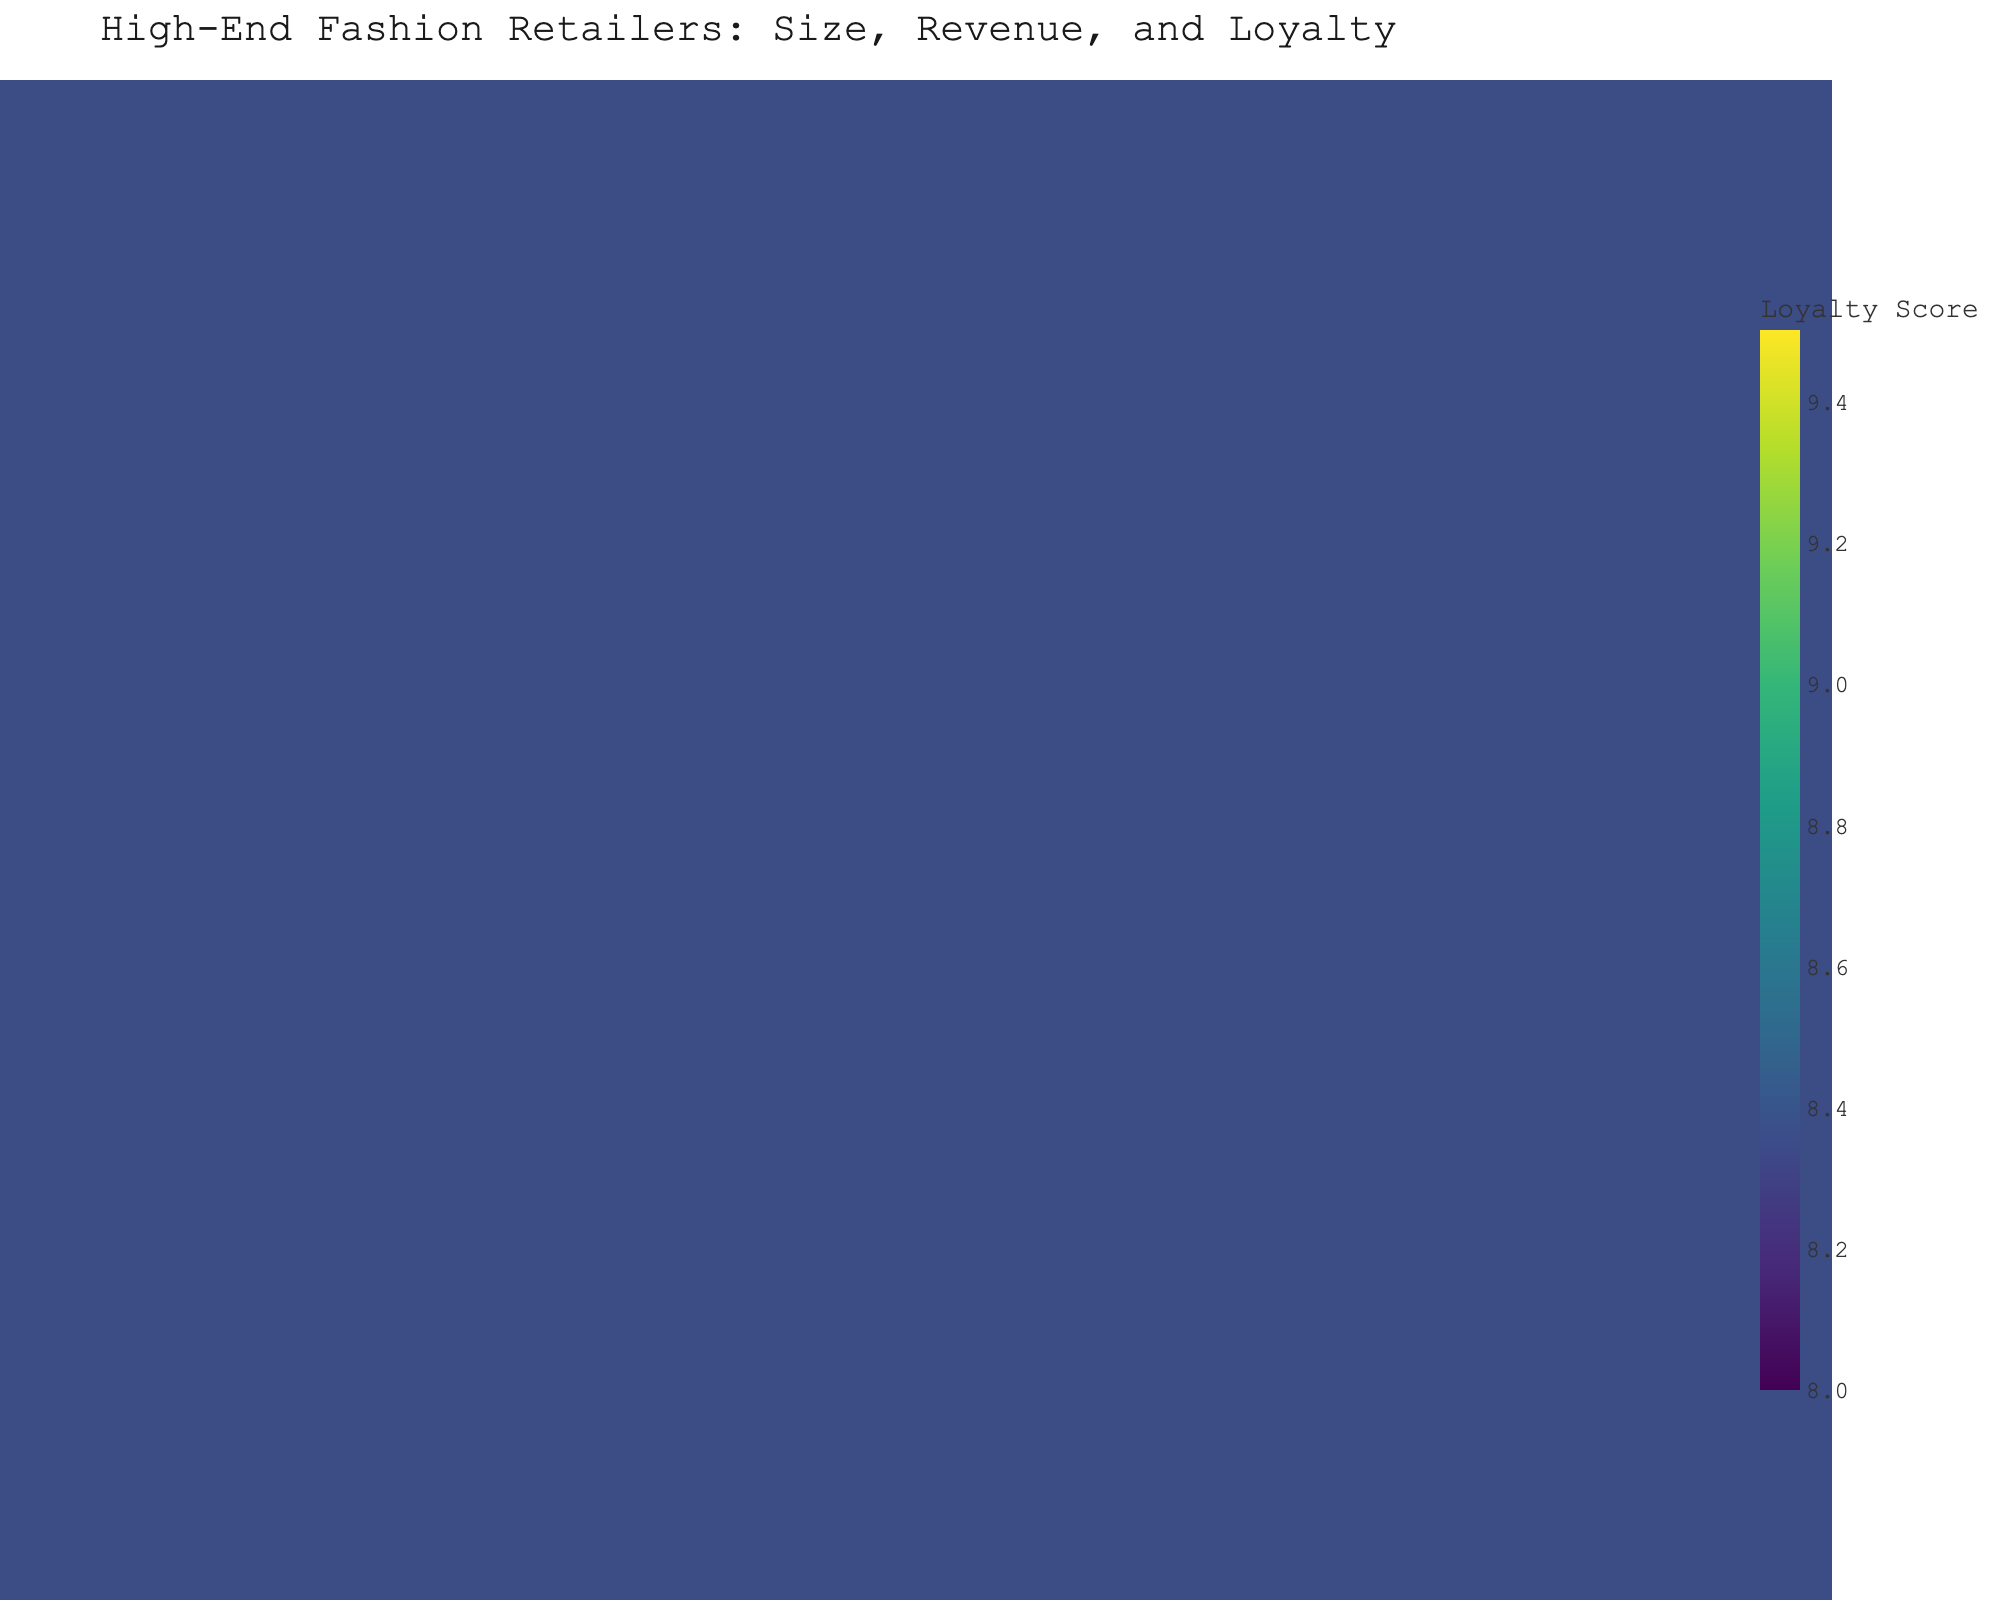What is the title of the plot? The title is usually displayed at the top of the figure, giving an overview of the chart's content.
Answer: High-End Fashion Retailers: Size, Revenue, and Loyalty Which store has the highest annual revenue? Look for the data point on the y-axis with the highest value and refer to the hover name.
Answer: Louis Vuitton How many stores are plotted in the figure? Count the number of distinct data points or markers in the scatter plot.
Answer: 15 Which store has the lowest customer loyalty score? Look for the data point on the z-axis with the lowest value and refer to the hover name.
Answer: Givenchy What is the range of store sizes in the plot? Identify the minimum and maximum values on the x-axis.
Answer: 2100 to 4200 sq ft Which store has both high revenue and high customer loyalty? Look for data points that are high on the y-axis and z-axis.
Answer: Louis Vuitton, Chanel, Hermès What is the average customer loyalty score of all stores combined? Sum all customer loyalty scores and divide by the number of stores.
Answer: (8.7 + 9.1 + 8.3 + 9.3 + 9.5 + 8.1 + 8.6 + 8.2 + 8.8 + 8.4 + 8.5 + 9.0 + 8.0 + 8.7 + 8.3) / 15 = 8.65 Which store has a higher annual revenue, Hermès or Chanel? Compare the y-axis values for Hermès and Chanel.
Answer: Chanel Is there any correlation between store size and annual revenue in the plot? Observe the distribution of data points along the x and y axes; if clusters or a trend are present, describe the nature of the correlation.
Answer: Positive correlation Which store has the smallest size but still maintains a relatively high customer loyalty score? Look for the smallest x-axis value and check corresponding z-axis values.
Answer: Givenchy 